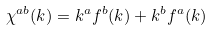<formula> <loc_0><loc_0><loc_500><loc_500>\chi ^ { a b } ( k ) = k ^ { a } f ^ { b } ( k ) + k ^ { b } f ^ { a } ( k )</formula> 